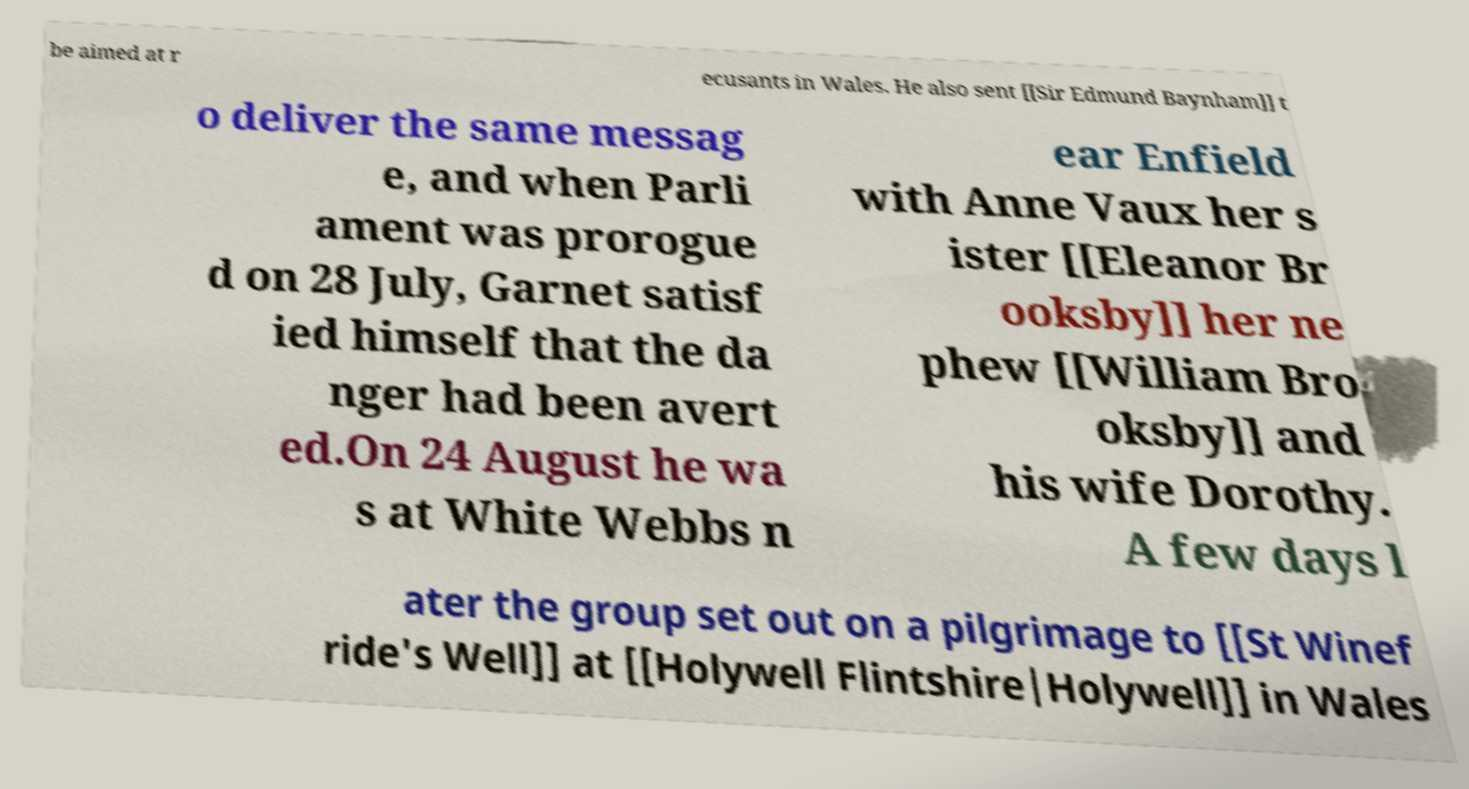I need the written content from this picture converted into text. Can you do that? be aimed at r ecusants in Wales. He also sent [[Sir Edmund Baynham]] t o deliver the same messag e, and when Parli ament was prorogue d on 28 July, Garnet satisf ied himself that the da nger had been avert ed.On 24 August he wa s at White Webbs n ear Enfield with Anne Vaux her s ister [[Eleanor Br ooksby]] her ne phew [[William Bro oksby]] and his wife Dorothy. A few days l ater the group set out on a pilgrimage to [[St Winef ride's Well]] at [[Holywell Flintshire|Holywell]] in Wales 